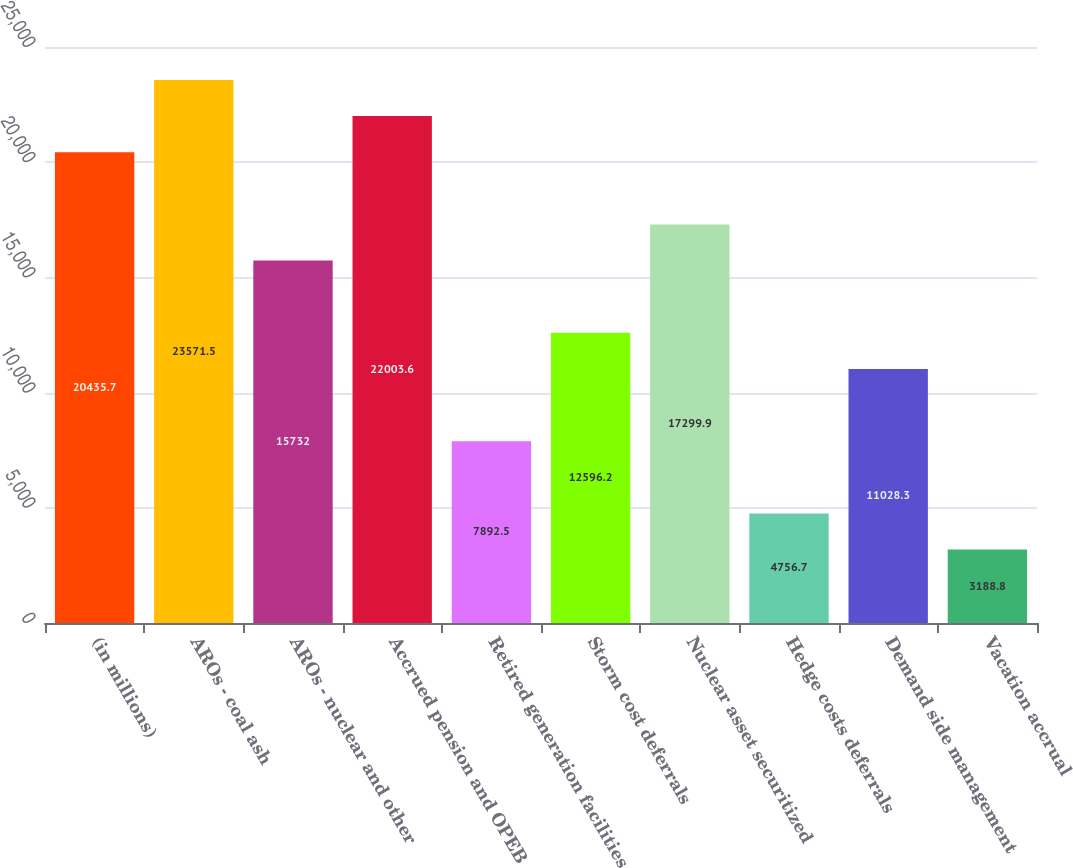Convert chart. <chart><loc_0><loc_0><loc_500><loc_500><bar_chart><fcel>(in millions)<fcel>AROs - coal ash<fcel>AROs - nuclear and other<fcel>Accrued pension and OPEB<fcel>Retired generation facilities<fcel>Storm cost deferrals<fcel>Nuclear asset securitized<fcel>Hedge costs deferrals<fcel>Demand side management<fcel>Vacation accrual<nl><fcel>20435.7<fcel>23571.5<fcel>15732<fcel>22003.6<fcel>7892.5<fcel>12596.2<fcel>17299.9<fcel>4756.7<fcel>11028.3<fcel>3188.8<nl></chart> 